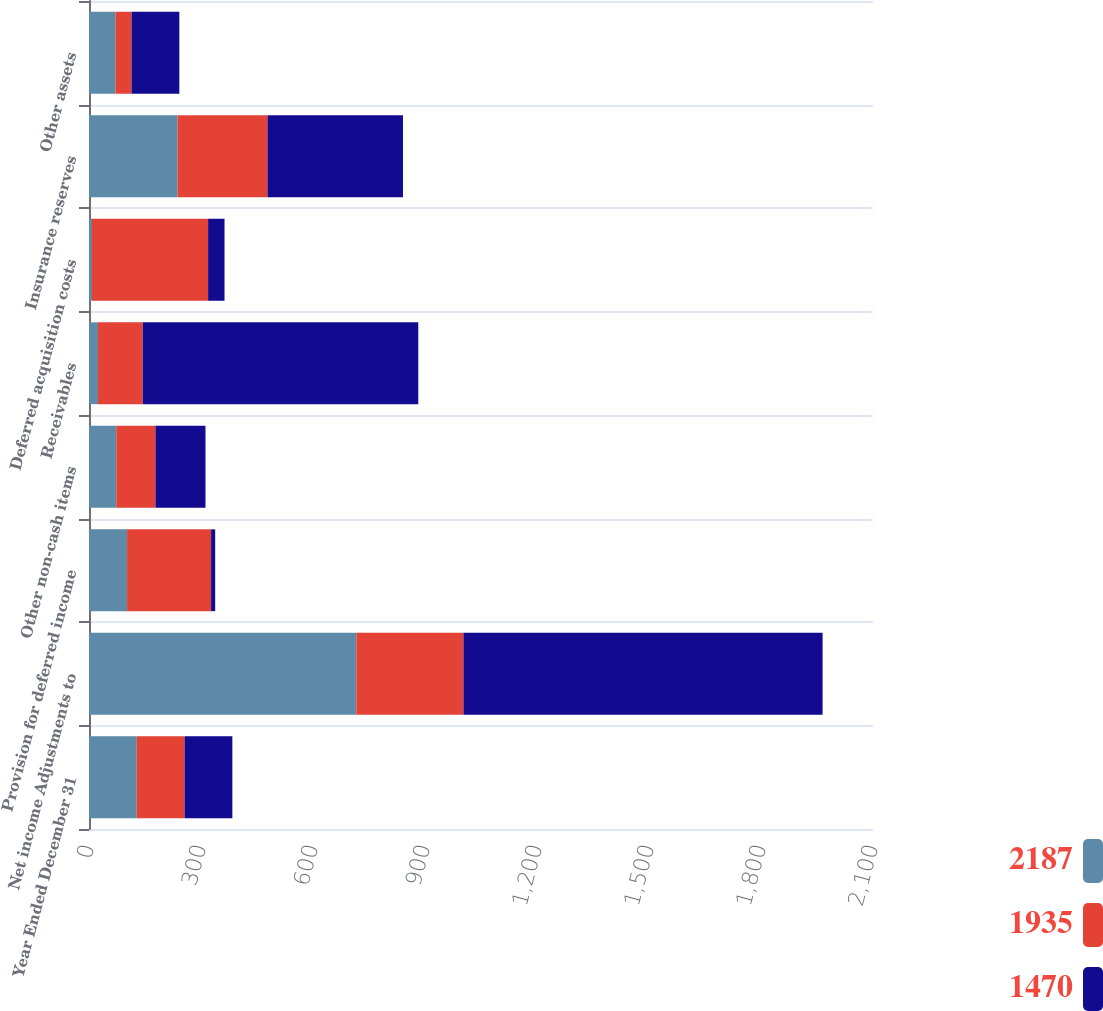Convert chart to OTSL. <chart><loc_0><loc_0><loc_500><loc_500><stacked_bar_chart><ecel><fcel>Year Ended December 31<fcel>Net income Adjustments to<fcel>Provision for deferred income<fcel>Other non-cash items<fcel>Receivables<fcel>Deferred acquisition costs<fcel>Insurance reserves<fcel>Other assets<nl><fcel>2187<fcel>128<fcel>716<fcel>102<fcel>73<fcel>24<fcel>8<fcel>237<fcel>71<nl><fcel>1935<fcel>128<fcel>287<fcel>225<fcel>105<fcel>120<fcel>311<fcel>241<fcel>43<nl><fcel>1470<fcel>128<fcel>962<fcel>11<fcel>134<fcel>738<fcel>44<fcel>363<fcel>128<nl></chart> 